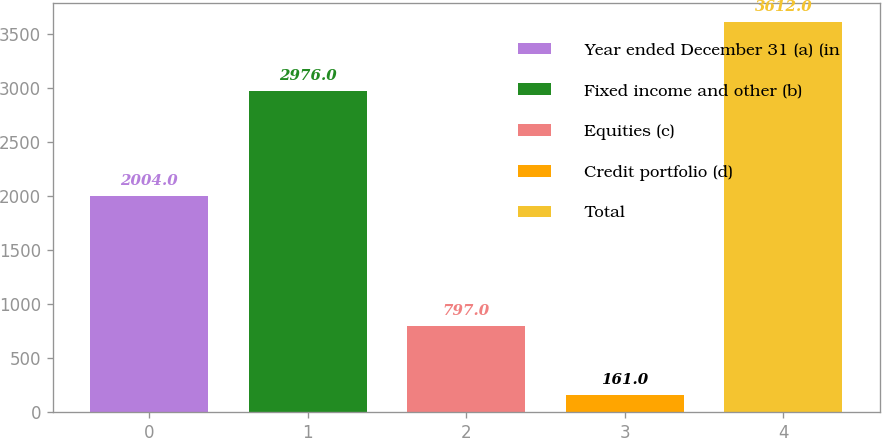Convert chart. <chart><loc_0><loc_0><loc_500><loc_500><bar_chart><fcel>Year ended December 31 (a) (in<fcel>Fixed income and other (b)<fcel>Equities (c)<fcel>Credit portfolio (d)<fcel>Total<nl><fcel>2004<fcel>2976<fcel>797<fcel>161<fcel>3612<nl></chart> 